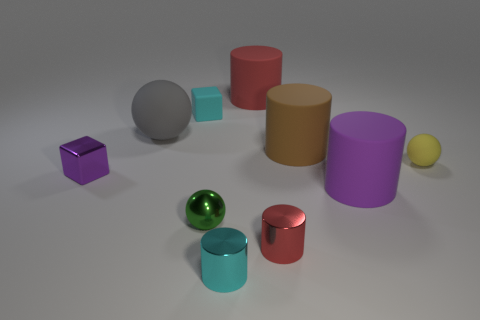Are the large cylinder in front of the tiny purple shiny block and the small yellow sphere made of the same material?
Your response must be concise. Yes. What shape is the tiny shiny thing that is on the right side of the green object and behind the small cyan cylinder?
Offer a terse response. Cylinder. Is there a brown matte cylinder that is on the right side of the cylinder that is in front of the red metal thing?
Your answer should be very brief. Yes. How many other objects are the same material as the large gray thing?
Give a very brief answer. 5. Do the small object that is in front of the small red cylinder and the red object in front of the large purple matte thing have the same shape?
Offer a very short reply. Yes. Does the tiny red cylinder have the same material as the cyan cylinder?
Offer a very short reply. Yes. How big is the matte ball left of the red cylinder that is behind the rubber sphere that is to the left of the tiny red metallic thing?
Your response must be concise. Large. What number of other objects are the same color as the metallic block?
Offer a terse response. 1. There is a green object that is the same size as the metallic block; what shape is it?
Make the answer very short. Sphere. What number of big things are either green metal cubes or red objects?
Offer a very short reply. 1. 